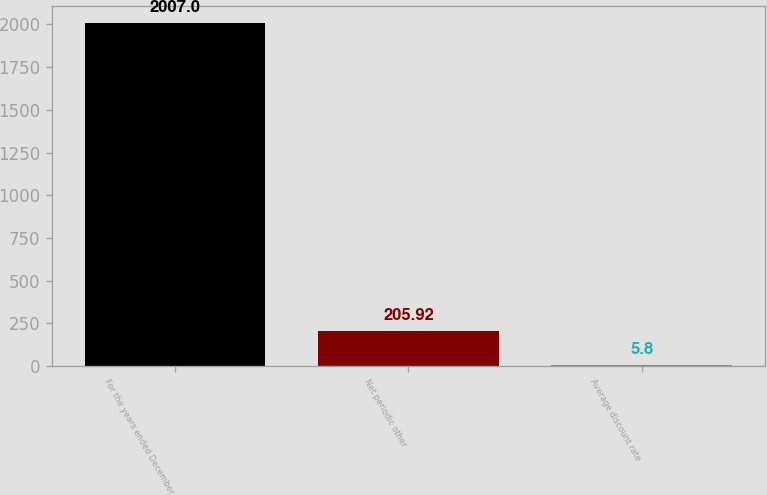<chart> <loc_0><loc_0><loc_500><loc_500><bar_chart><fcel>For the years ended December<fcel>Net periodic other<fcel>Average discount rate<nl><fcel>2007<fcel>205.92<fcel>5.8<nl></chart> 